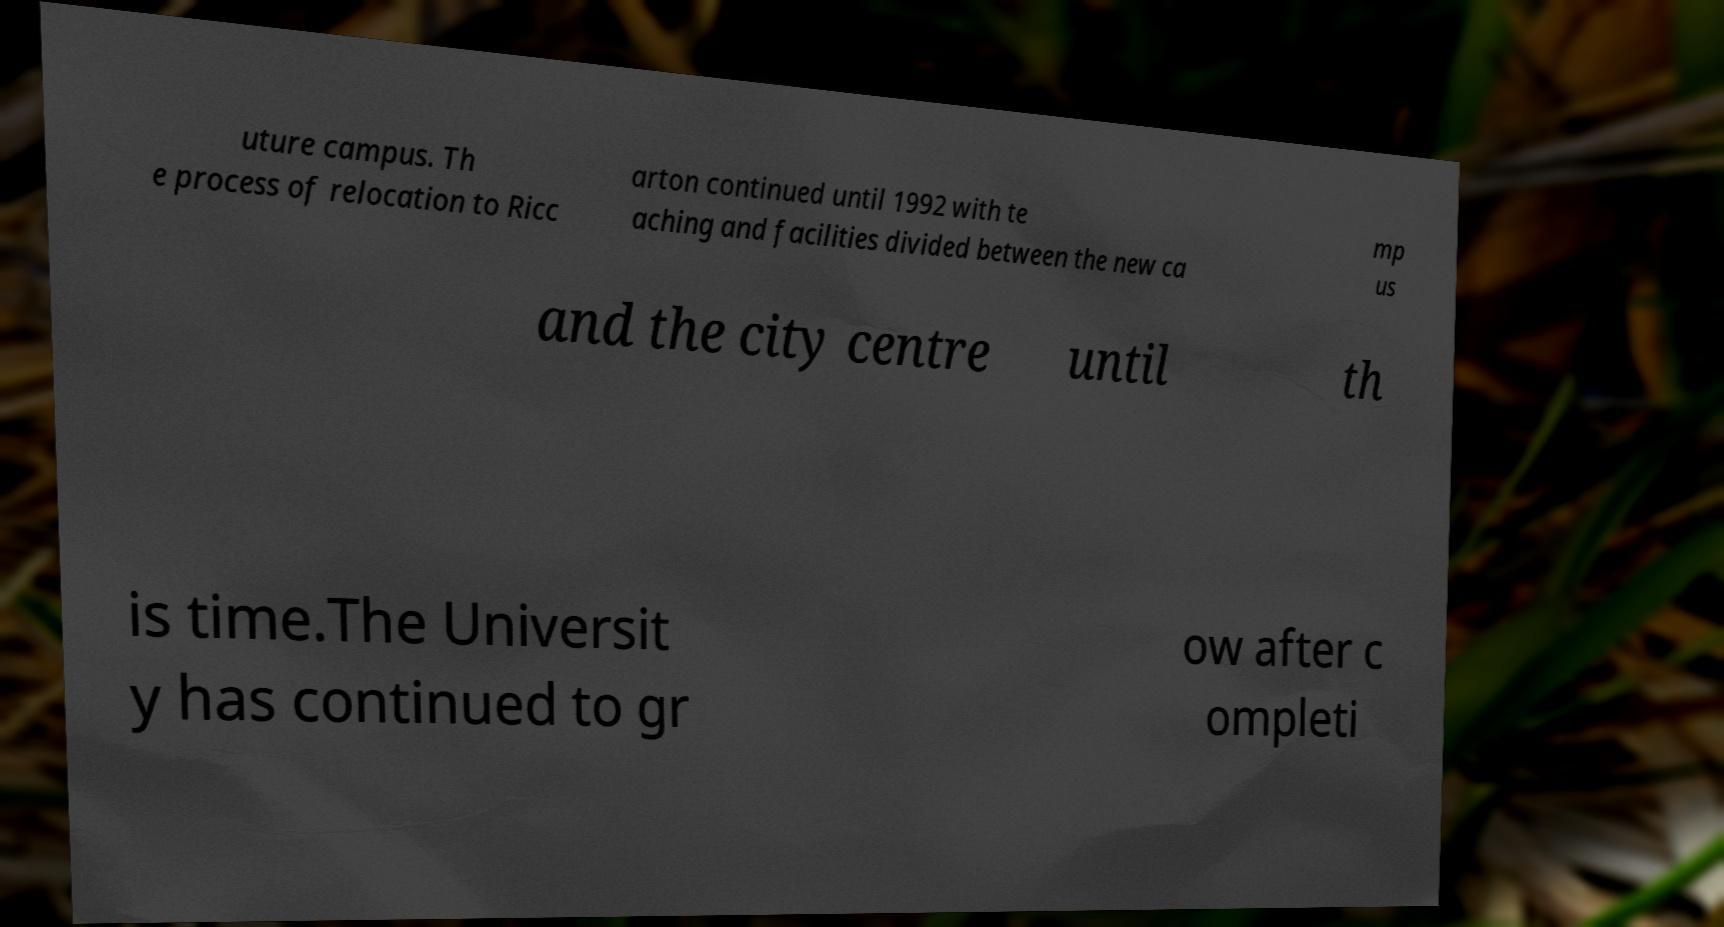Can you read and provide the text displayed in the image?This photo seems to have some interesting text. Can you extract and type it out for me? uture campus. Th e process of relocation to Ricc arton continued until 1992 with te aching and facilities divided between the new ca mp us and the city centre until th is time.The Universit y has continued to gr ow after c ompleti 